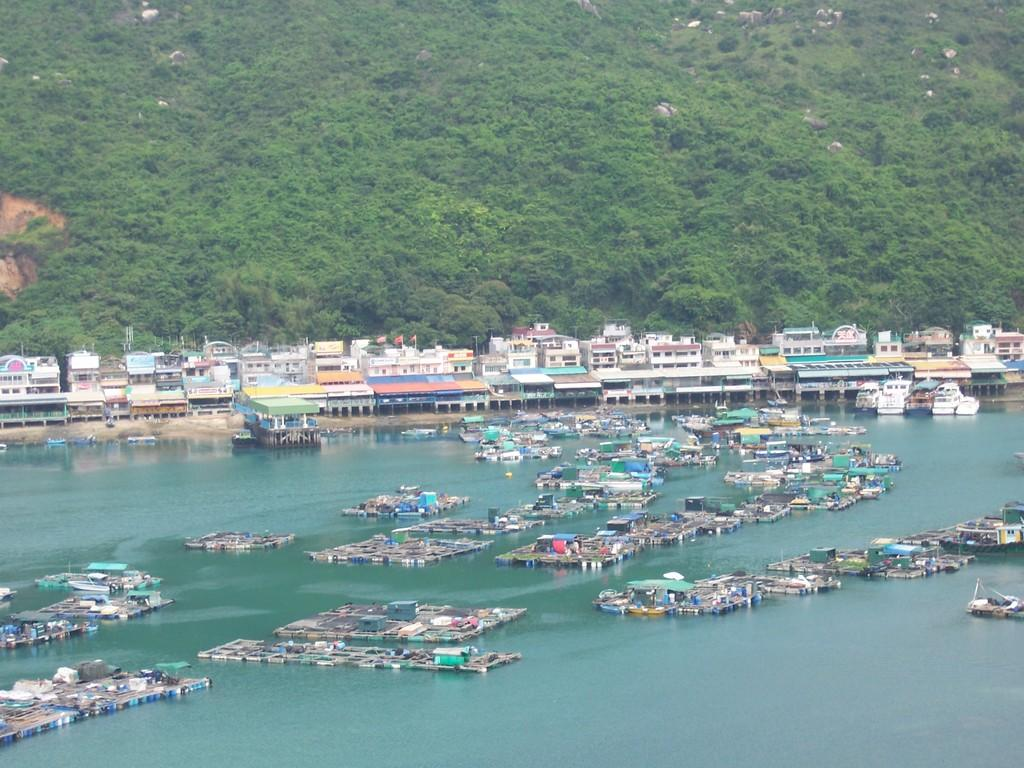What is happening to the objects in the image? The objects are floating on the water in the image. What can be seen in the distance behind the objects? There are buildings and trees in the background of the image. What type of soup is being served in the image? There is no soup present in the image; it features objects floating on water with buildings and trees in the background. 